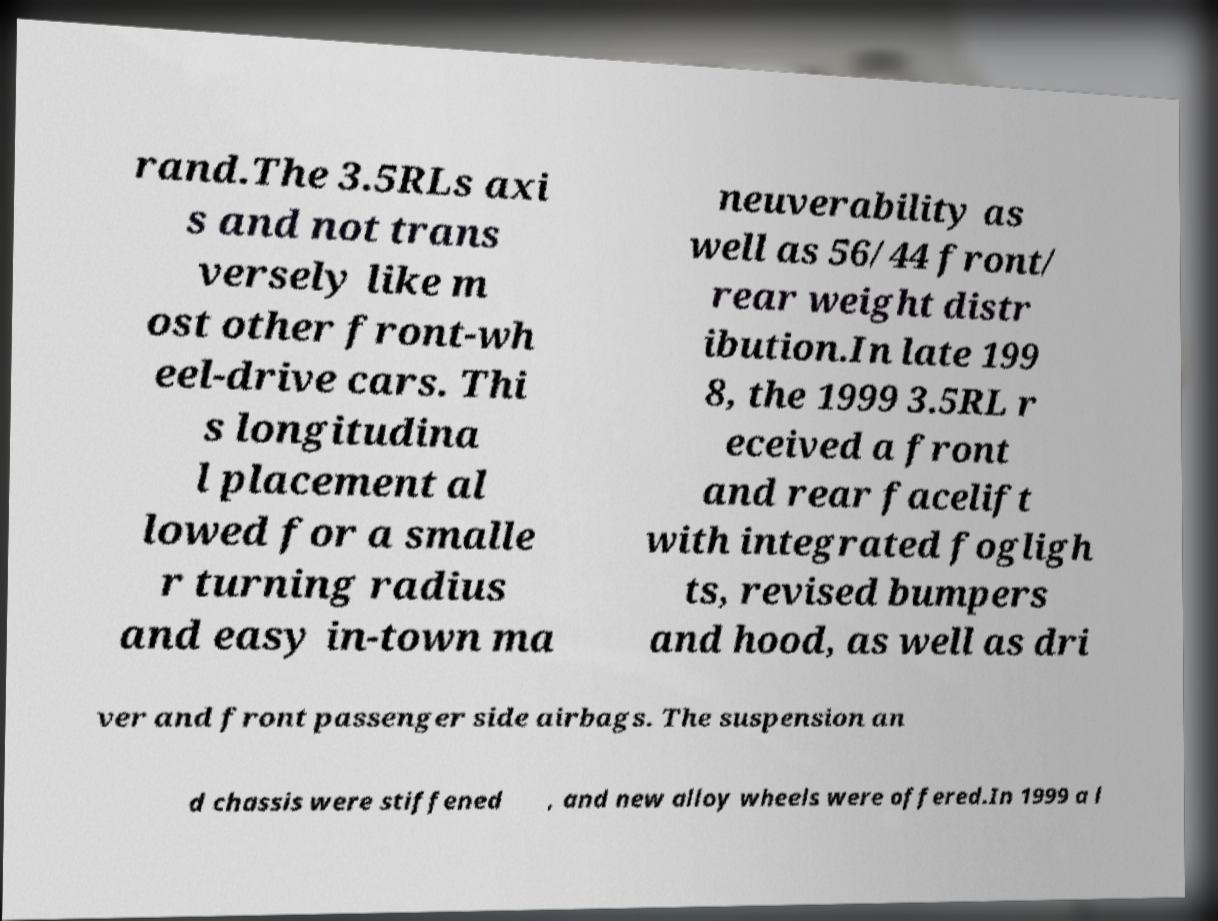Could you extract and type out the text from this image? rand.The 3.5RLs axi s and not trans versely like m ost other front-wh eel-drive cars. Thi s longitudina l placement al lowed for a smalle r turning radius and easy in-town ma neuverability as well as 56/44 front/ rear weight distr ibution.In late 199 8, the 1999 3.5RL r eceived a front and rear facelift with integrated fogligh ts, revised bumpers and hood, as well as dri ver and front passenger side airbags. The suspension an d chassis were stiffened , and new alloy wheels were offered.In 1999 a l 